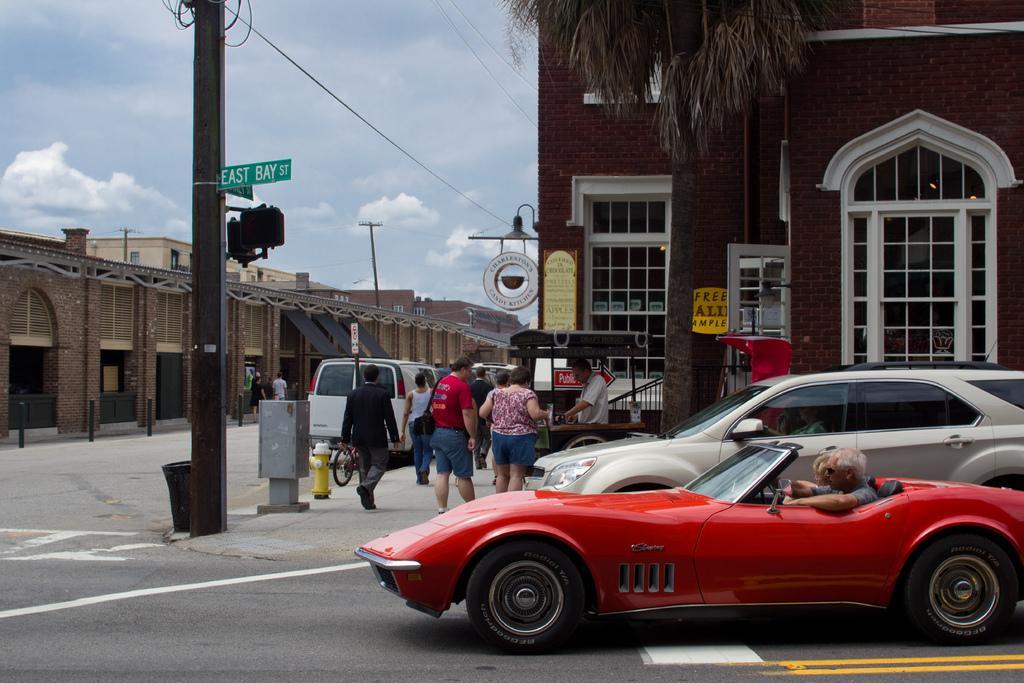In one or two sentences, can you explain what this image depicts? In this image I can see a car which is red in color on the road and few persons in the car and I can see few other vehicles on the road, few persons standing on the sidewalk, few metal poles, a sign board attached to the metal pole, a dustbin which is black in color and in the background I can see few buildings, a tree and the sky. 